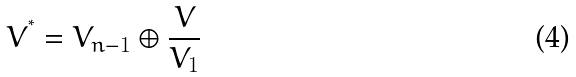Convert formula to latex. <formula><loc_0><loc_0><loc_500><loc_500>V ^ { ^ { * } } = V _ { n - 1 } \oplus \frac { V } { V _ { 1 } }</formula> 